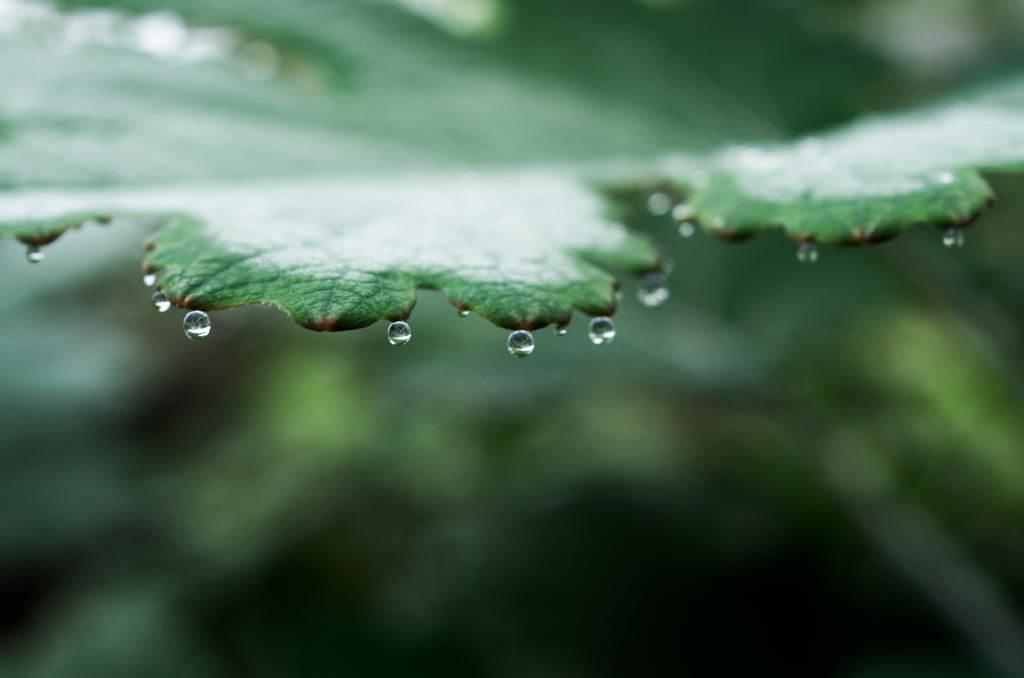What is present in the image that is related to water? There are water drops in the image. Where are the water drops coming from? The water drops are falling from a leaf. What type of soup is being served in the image? There is no soup present in the image; it features water drops falling from a leaf. What is the chance of the flowers blooming in the image? There are no flowers present in the image, so it is not possible to determine the chance of them blooming. 